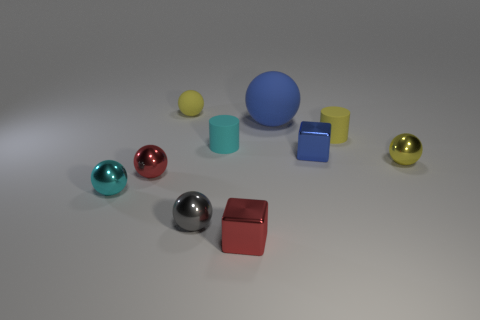How many yellow balls must be subtracted to get 1 yellow balls? 1 Subtract all red metallic balls. How many balls are left? 5 Subtract all cyan cylinders. How many cylinders are left? 1 Subtract 1 red cubes. How many objects are left? 9 Subtract all spheres. How many objects are left? 4 Subtract 2 cylinders. How many cylinders are left? 0 Subtract all red cylinders. Subtract all yellow spheres. How many cylinders are left? 2 Subtract all blue balls. How many blue blocks are left? 1 Subtract all big matte things. Subtract all blue cubes. How many objects are left? 8 Add 7 tiny cyan things. How many tiny cyan things are left? 9 